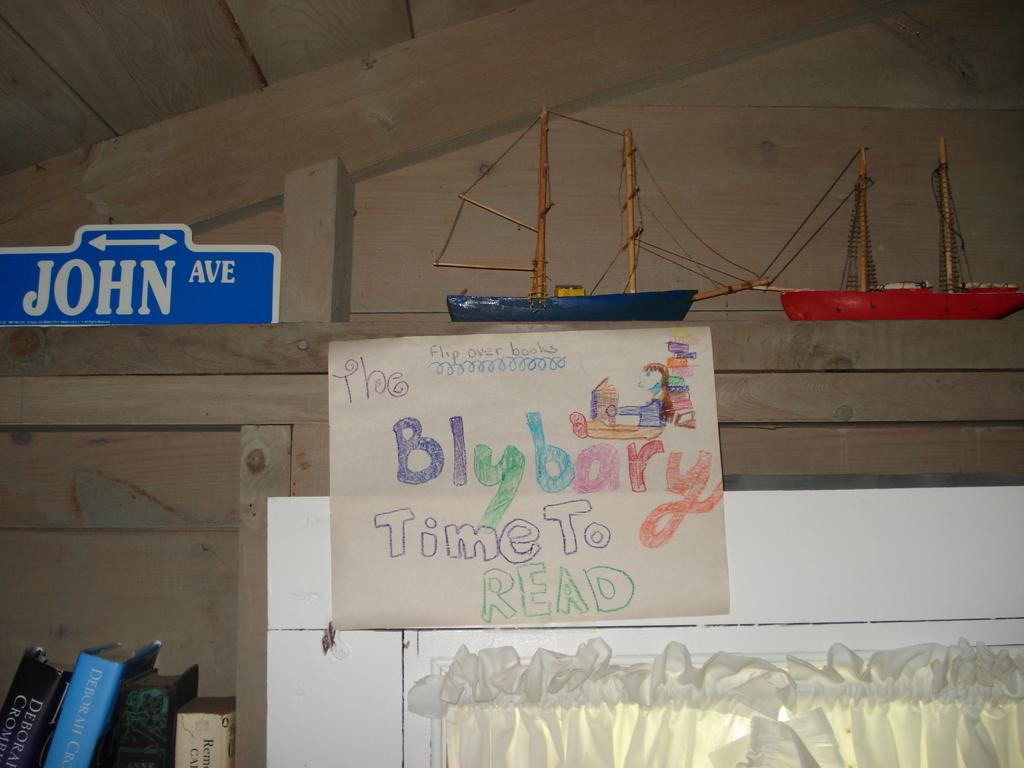What time is it?
Offer a terse response. To read. 